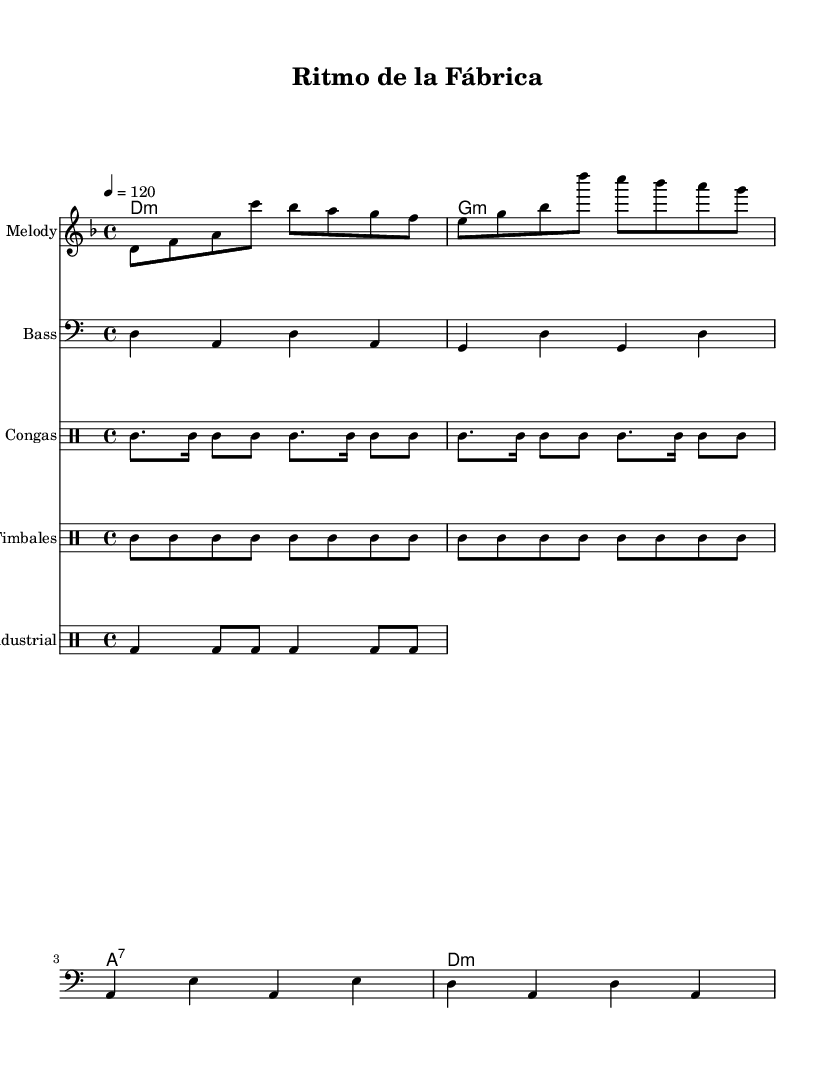What is the key signature of this music? The key signature is indicated at the beginning of the piece, showing one flat, which corresponds to D minor.
Answer: D minor What is the time signature used in this piece? The time signature is found at the beginning of the music, displayed as a fraction. It shows 4 beats per measure, specifically noted as 4/4.
Answer: 4/4 What is the tempo marking indicated in the score? The tempo marking is shown at the start of the piece, stating that the speed is 120 beats per minute, denoted in quarter notes.
Answer: 120 How many different percussion instruments are indicated in the score? The score lists three types of percussion instruments: Congas, Timbales, and Industrial drums.
Answer: Three What chord is played for the first measure? The first measure shows a D minor chord indicated in the chord names section, represented by the symbol 'd1:m'.
Answer: D minor Which rhythmic elements are associated with the Latin fusion style? The rhythmic elements can be seen in the drum parts, notably the congas and timbales parts, which follow traditional Latin patterns that emphasize syncopation.
Answer: Syncopation How many beats are in each measure of the bass line? The bass line is written in 4/4 time, meaning there are four beats in each measure, consistent throughout.
Answer: Four 